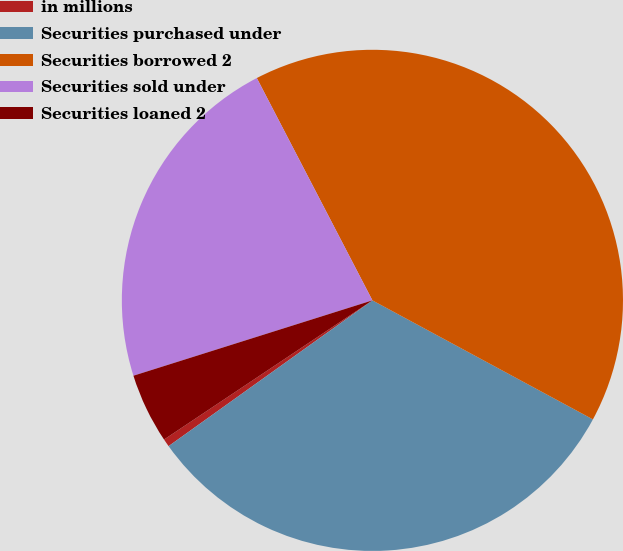Convert chart. <chart><loc_0><loc_0><loc_500><loc_500><pie_chart><fcel>in millions<fcel>Securities purchased under<fcel>Securities borrowed 2<fcel>Securities sold under<fcel>Securities loaned 2<nl><fcel>0.51%<fcel>32.24%<fcel>40.51%<fcel>22.23%<fcel>4.51%<nl></chart> 